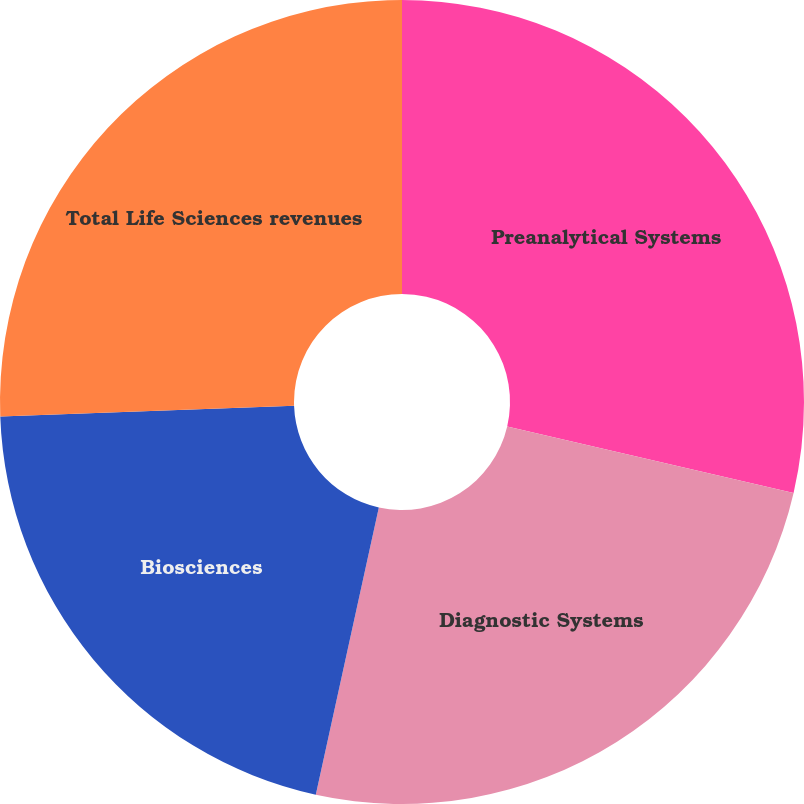Convert chart. <chart><loc_0><loc_0><loc_500><loc_500><pie_chart><fcel>Preanalytical Systems<fcel>Diagnostic Systems<fcel>Biosciences<fcel>Total Life Sciences revenues<nl><fcel>28.63%<fcel>24.81%<fcel>20.99%<fcel>25.57%<nl></chart> 